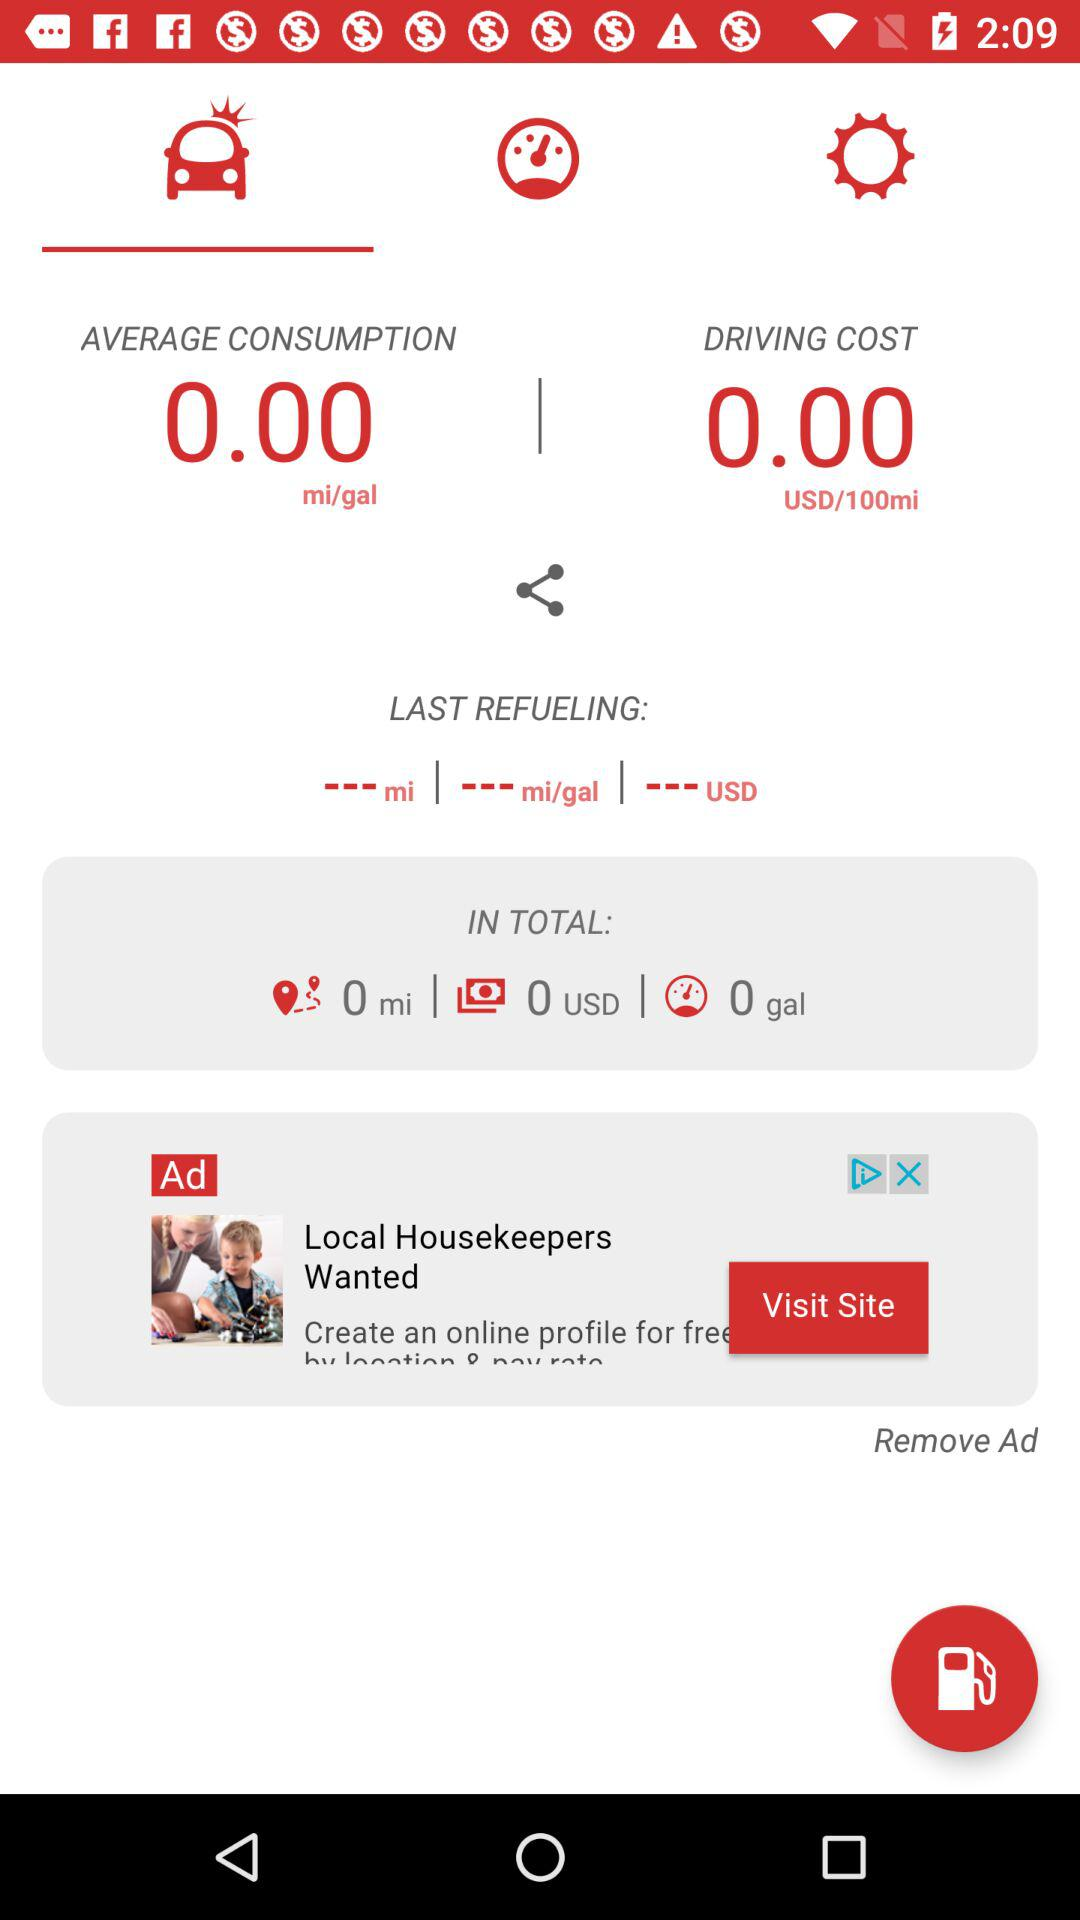What is the average consumption? The average consumption is 0 mi/gal. 